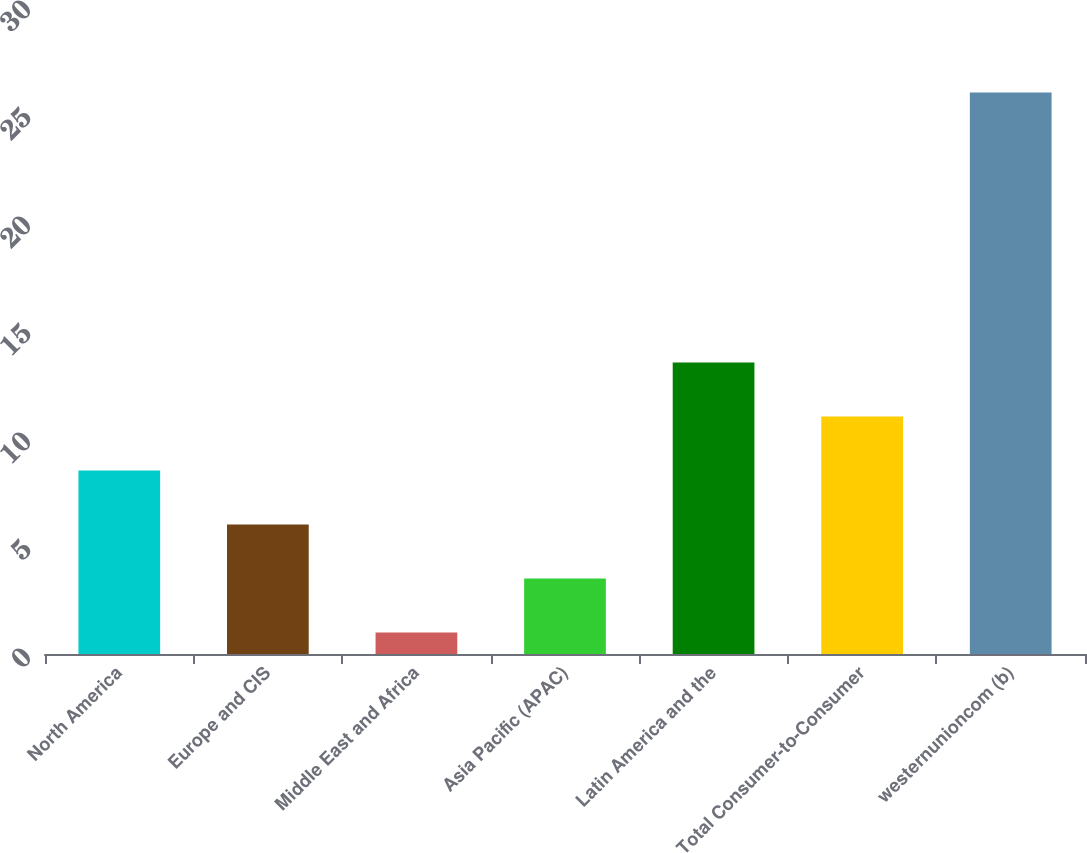Convert chart to OTSL. <chart><loc_0><loc_0><loc_500><loc_500><bar_chart><fcel>North America<fcel>Europe and CIS<fcel>Middle East and Africa<fcel>Asia Pacific (APAC)<fcel>Latin America and the<fcel>Total Consumer-to-Consumer<fcel>westernunioncom (b)<nl><fcel>8.5<fcel>6<fcel>1<fcel>3.5<fcel>13.5<fcel>11<fcel>26<nl></chart> 